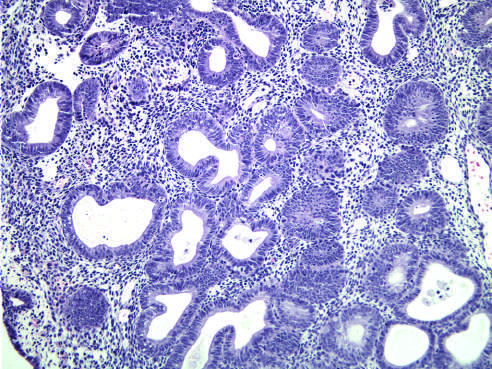how is hyperplasia without atypia characterized?
Answer the question using a single word or phrase. By nests of closely packed glands 